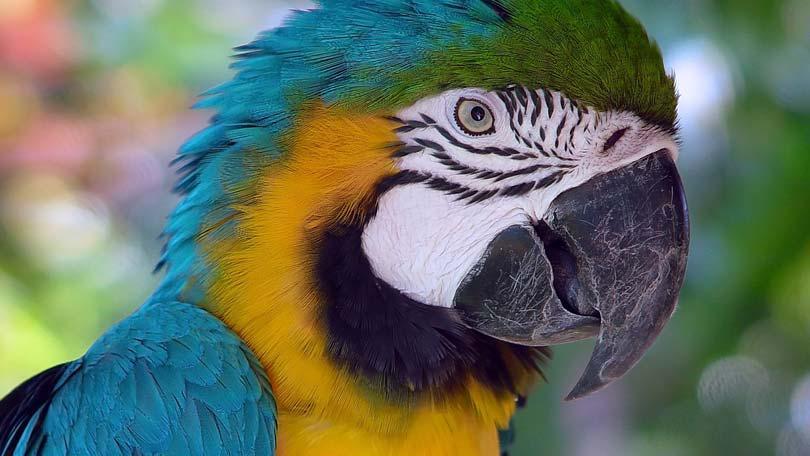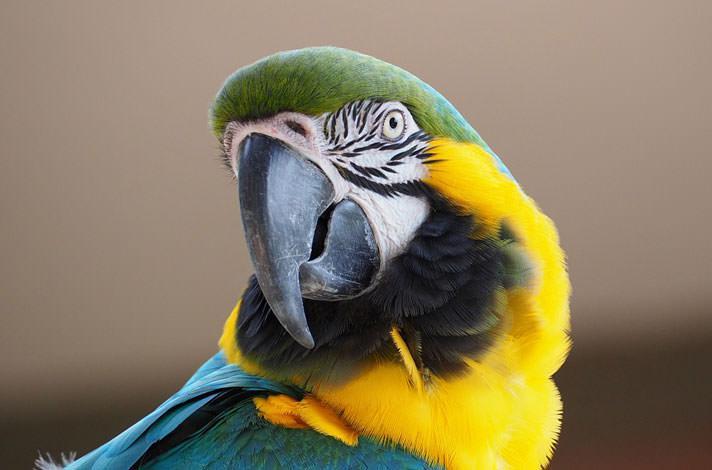The first image is the image on the left, the second image is the image on the right. Given the left and right images, does the statement "There are two parrots." hold true? Answer yes or no. Yes. The first image is the image on the left, the second image is the image on the right. For the images shown, is this caption "There is no more than one bird in each image." true? Answer yes or no. Yes. 